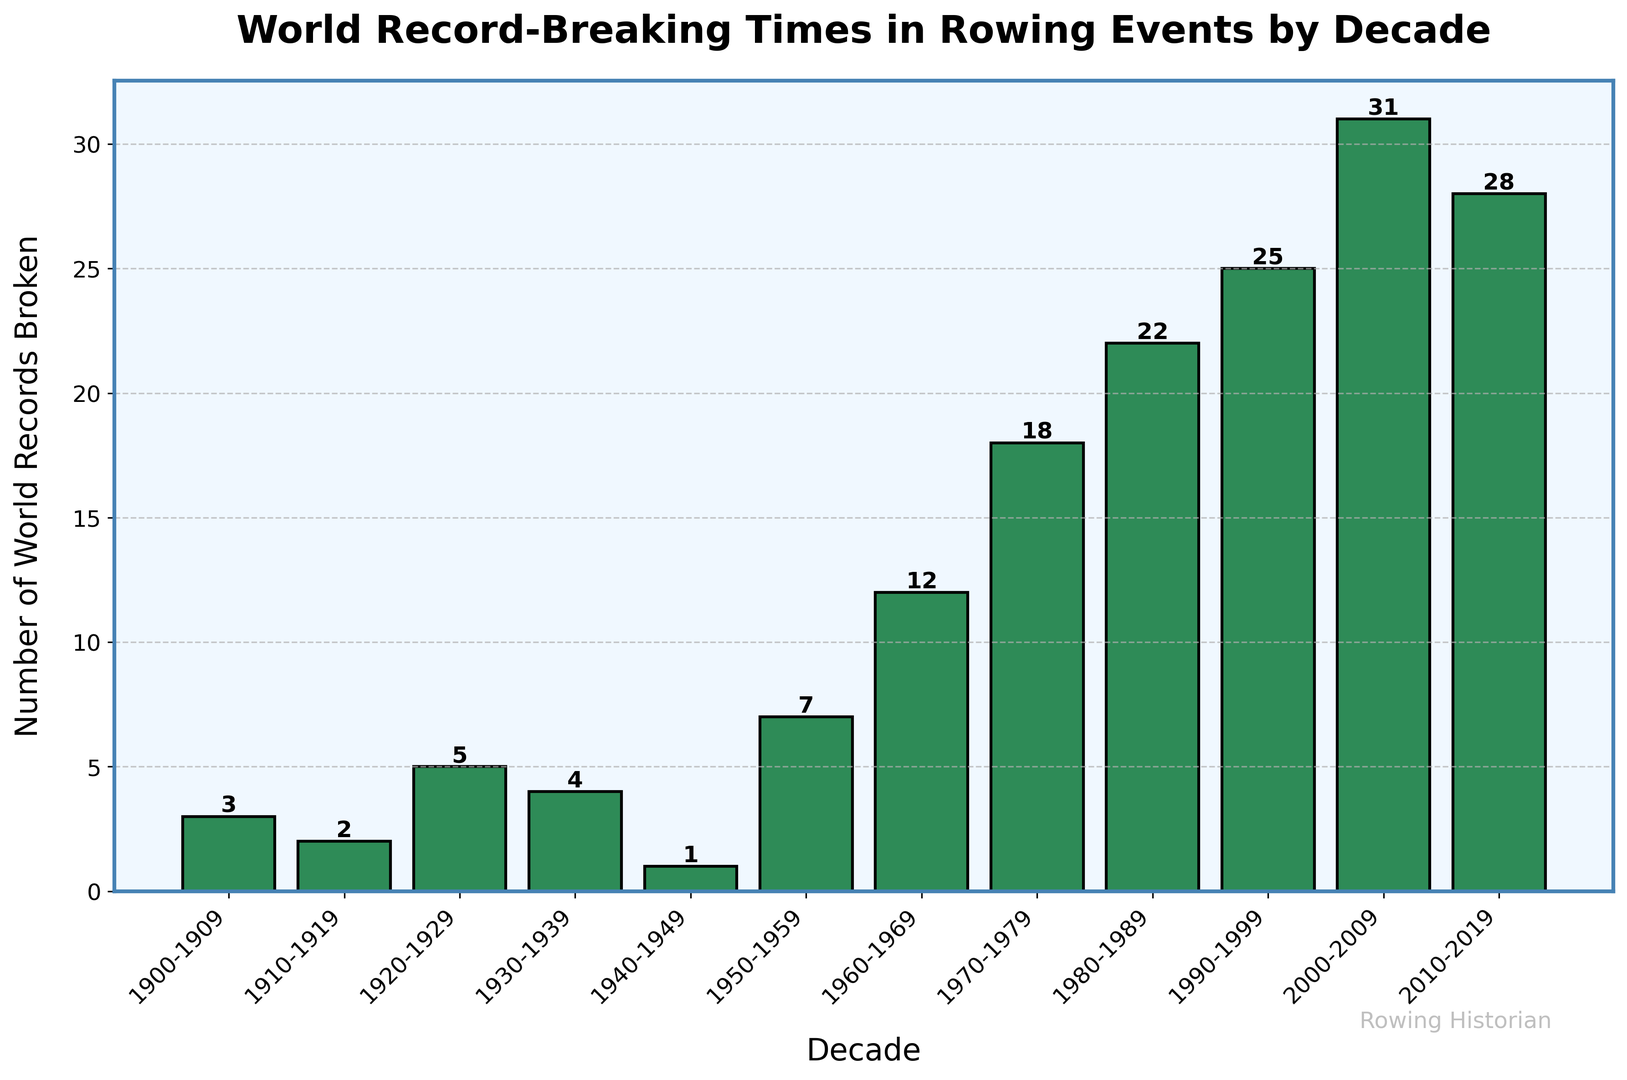Which decade had the highest number of world records broken? To find the decade with the highest number of world records, look for the tallest bar in the histogram. Identify its corresponding decade from the x-axis labels, which is 2000-2009 with a count of 31.
Answer: 2000-2009 How many world records were broken in the 1960s? Identify the bar for the 1960-1969 decade and note its height. The height of the bar represents the number of world records broken, which is 12.
Answer: 12 What is the combined total of world records broken in the 1970s and 1980s? Find the heights of the bars for the 1970-1979 and 1980-1989 decades and sum them up. The respective counts are 18 and 22, so the combined total is 18 + 22 = 40.
Answer: 40 Which decade experienced a decline in the number of world records broken compared to the previous decade? Identify each pair of consecutive decades and compare their heights. Notice that the number of records broken in 2010-2019 (28) is less than in 2000-2009 (31).
Answer: 2010-2019 Between 1920-1929 and 1930-1939, which decade saw more world records broken? Compare the heights of the bars for the 1920-1929 and 1930-1939 decades. The bar for 1920-1929 is higher with a count of 5 compared to 4 in 1930-1939.
Answer: 1920-1929 What is the sum of world records broken from 1900-1909 to 1940-1949? Add the heights of the bars for the decades 1900-1909, 1910-1919, 1920-1929, 1930-1939, and 1940-1949. The respective counts are 3, 2, 5, 4, and 1. So, the sum is 3 + 2 + 5 + 4 + 1 = 15.
Answer: 15 What was the smallest number of world records broken in any decade? Look for the shortest bar in the histogram and note its height. The shortest bar represents the count of 1 in the decade 1940-1949.
Answer: 1 How much higher is the number of world records broken in 2000-2009 compared to 1960-1969? Subtract the number of records in 1960-1969 (12) from that in 2000-2009 (31). The difference is 31 - 12 = 19.
Answer: 19 What is the average number of world records broken per decade across the entire time range? First, sum the number of world records across all decades: 3 + 2 + 5 + 4 + 1 + 7 + 12 + 18 + 22 + 25 + 31 + 28 = 158. Then, divide by the number of decades (12). The average is 158 / 12 ≈ 13.17.
Answer: 13.17 